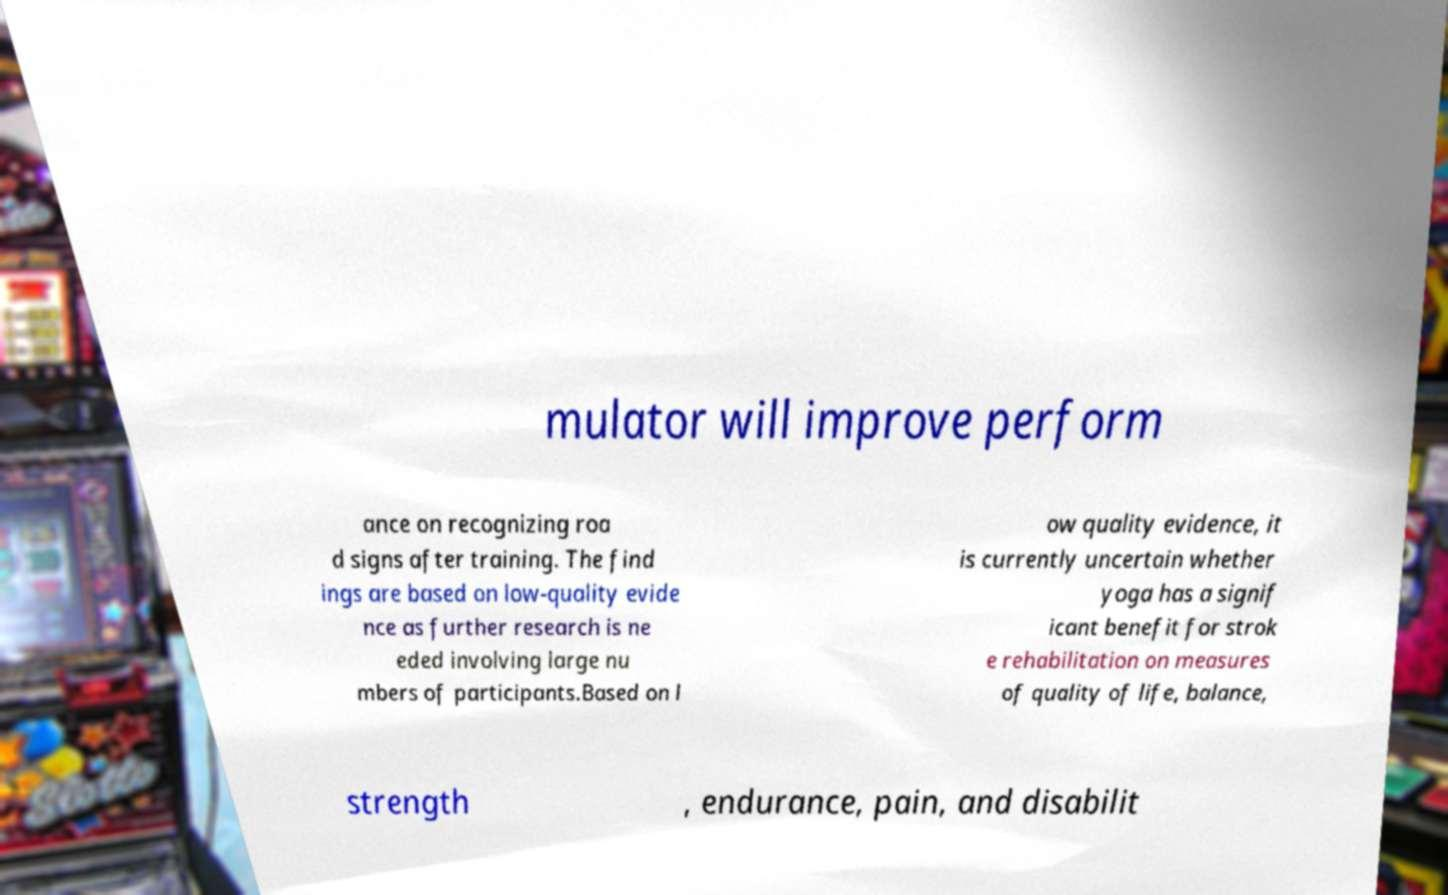Could you assist in decoding the text presented in this image and type it out clearly? mulator will improve perform ance on recognizing roa d signs after training. The find ings are based on low-quality evide nce as further research is ne eded involving large nu mbers of participants.Based on l ow quality evidence, it is currently uncertain whether yoga has a signif icant benefit for strok e rehabilitation on measures of quality of life, balance, strength , endurance, pain, and disabilit 